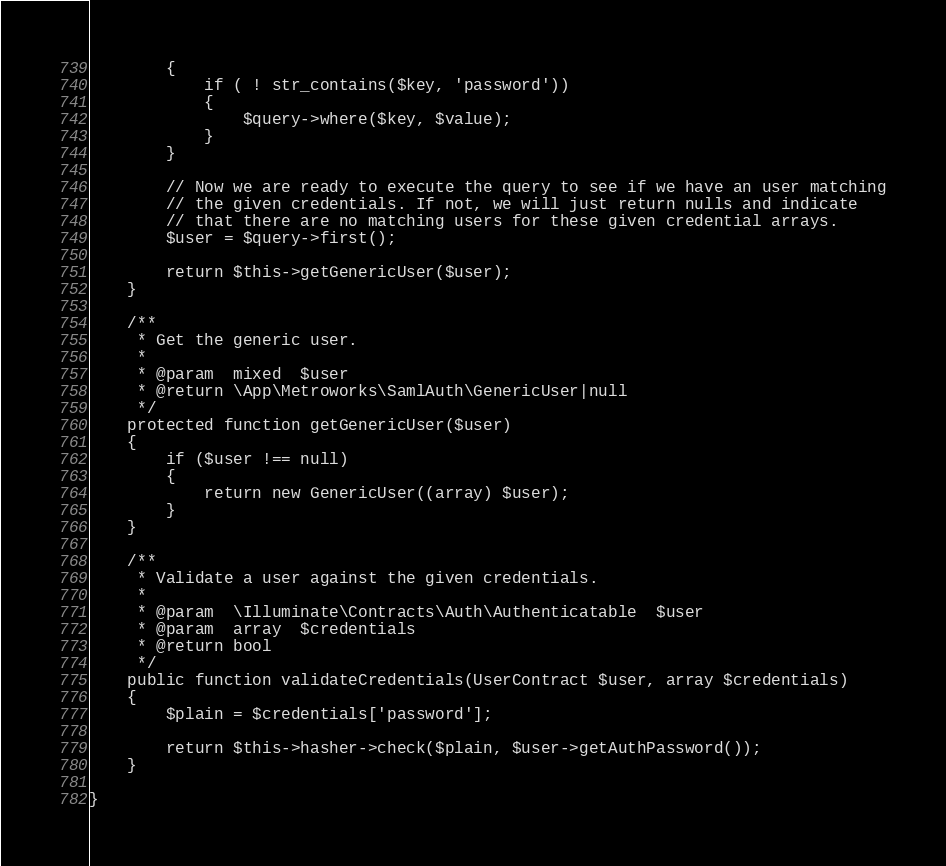<code> <loc_0><loc_0><loc_500><loc_500><_PHP_>		{
			if ( ! str_contains($key, 'password'))
			{
				$query->where($key, $value);
			}
		}

		// Now we are ready to execute the query to see if we have an user matching
		// the given credentials. If not, we will just return nulls and indicate
		// that there are no matching users for these given credential arrays.
		$user = $query->first();

		return $this->getGenericUser($user);
	}

	/**
	 * Get the generic user.
	 *
	 * @param  mixed  $user
	 * @return \App\Metroworks\SamlAuth\GenericUser|null
	 */
	protected function getGenericUser($user)
	{
		if ($user !== null)
		{
			return new GenericUser((array) $user);
		}
	}

	/**
	 * Validate a user against the given credentials.
	 *
	 * @param  \Illuminate\Contracts\Auth\Authenticatable  $user
	 * @param  array  $credentials
	 * @return bool
	 */
	public function validateCredentials(UserContract $user, array $credentials)
	{
		$plain = $credentials['password'];

		return $this->hasher->check($plain, $user->getAuthPassword());
	}

}
</code> 